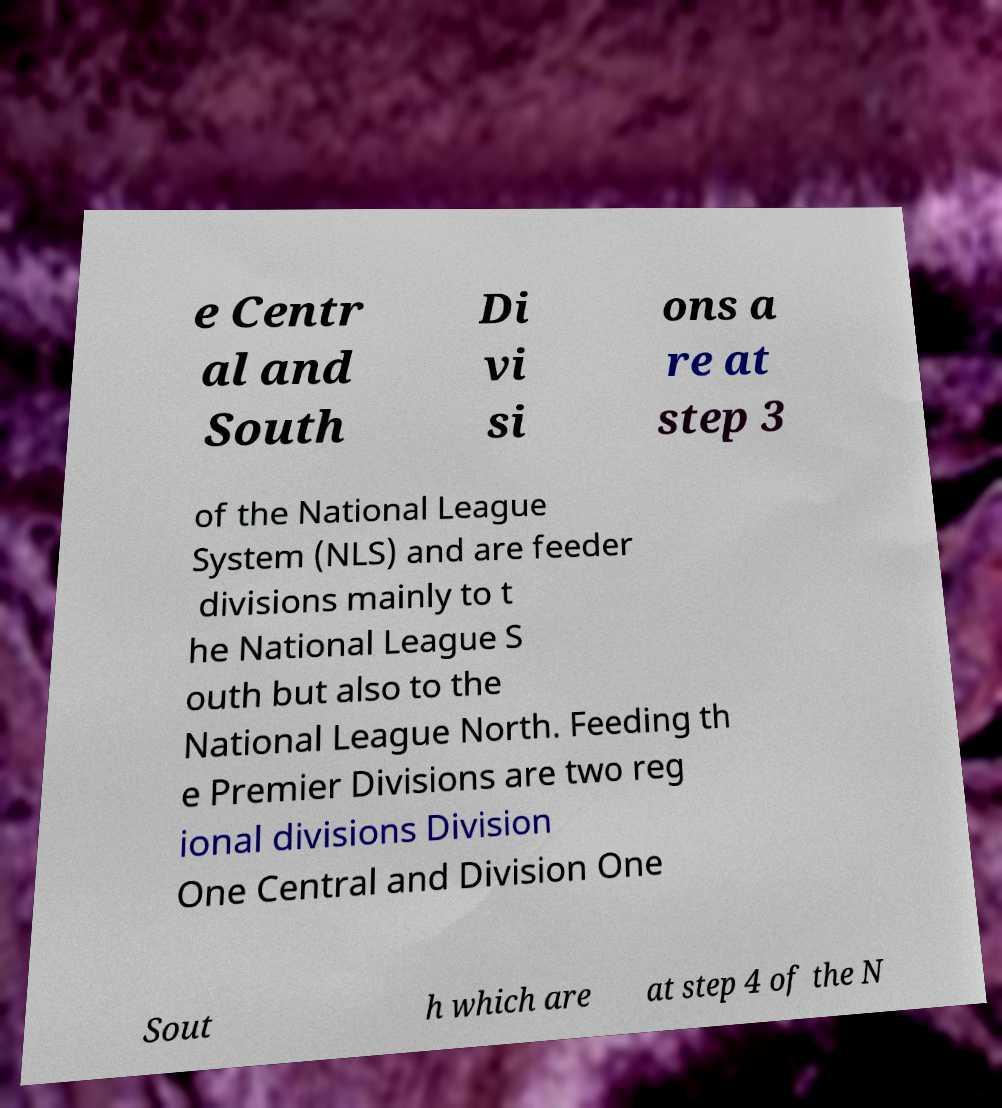There's text embedded in this image that I need extracted. Can you transcribe it verbatim? e Centr al and South Di vi si ons a re at step 3 of the National League System (NLS) and are feeder divisions mainly to t he National League S outh but also to the National League North. Feeding th e Premier Divisions are two reg ional divisions Division One Central and Division One Sout h which are at step 4 of the N 